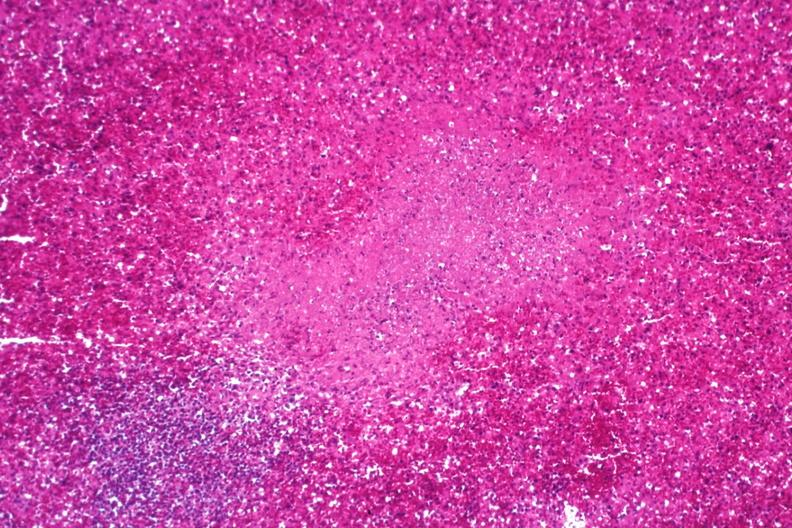s an opened peritoneal cavity cause by fibrous band strangulation present?
Answer the question using a single word or phrase. No 